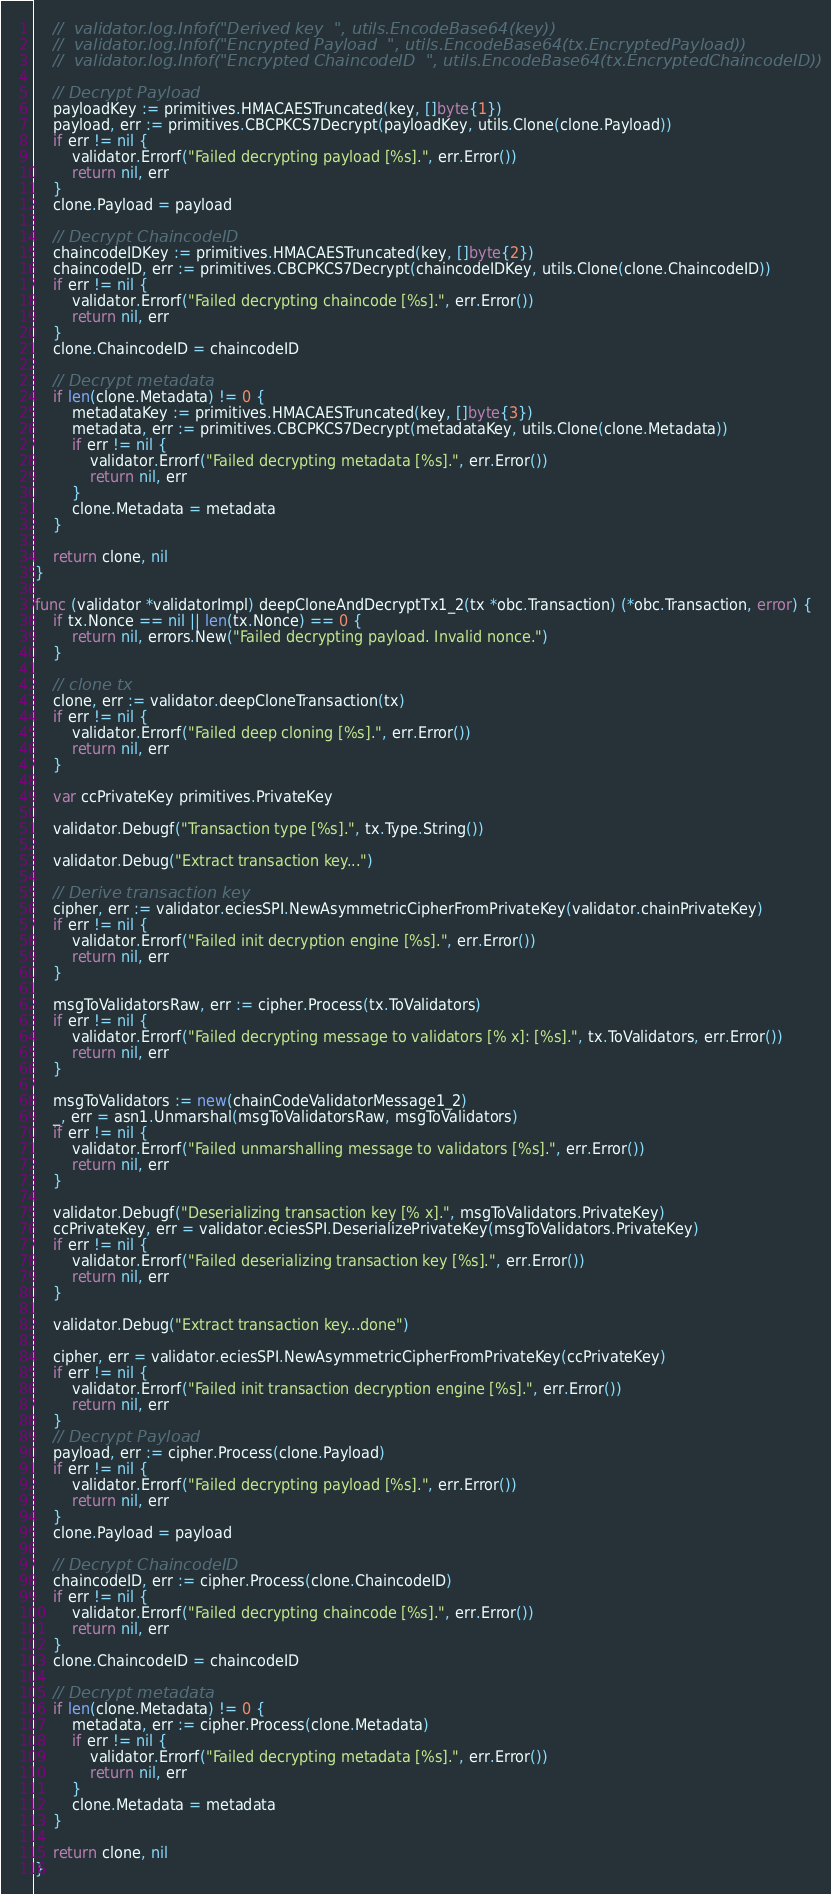<code> <loc_0><loc_0><loc_500><loc_500><_Go_>	//	validator.log.Infof("Derived key  ", utils.EncodeBase64(key))
	//	validator.log.Infof("Encrypted Payload  ", utils.EncodeBase64(tx.EncryptedPayload))
	//	validator.log.Infof("Encrypted ChaincodeID  ", utils.EncodeBase64(tx.EncryptedChaincodeID))

	// Decrypt Payload
	payloadKey := primitives.HMACAESTruncated(key, []byte{1})
	payload, err := primitives.CBCPKCS7Decrypt(payloadKey, utils.Clone(clone.Payload))
	if err != nil {
		validator.Errorf("Failed decrypting payload [%s].", err.Error())
		return nil, err
	}
	clone.Payload = payload

	// Decrypt ChaincodeID
	chaincodeIDKey := primitives.HMACAESTruncated(key, []byte{2})
	chaincodeID, err := primitives.CBCPKCS7Decrypt(chaincodeIDKey, utils.Clone(clone.ChaincodeID))
	if err != nil {
		validator.Errorf("Failed decrypting chaincode [%s].", err.Error())
		return nil, err
	}
	clone.ChaincodeID = chaincodeID

	// Decrypt metadata
	if len(clone.Metadata) != 0 {
		metadataKey := primitives.HMACAESTruncated(key, []byte{3})
		metadata, err := primitives.CBCPKCS7Decrypt(metadataKey, utils.Clone(clone.Metadata))
		if err != nil {
			validator.Errorf("Failed decrypting metadata [%s].", err.Error())
			return nil, err
		}
		clone.Metadata = metadata
	}

	return clone, nil
}

func (validator *validatorImpl) deepCloneAndDecryptTx1_2(tx *obc.Transaction) (*obc.Transaction, error) {
	if tx.Nonce == nil || len(tx.Nonce) == 0 {
		return nil, errors.New("Failed decrypting payload. Invalid nonce.")
	}

	// clone tx
	clone, err := validator.deepCloneTransaction(tx)
	if err != nil {
		validator.Errorf("Failed deep cloning [%s].", err.Error())
		return nil, err
	}

	var ccPrivateKey primitives.PrivateKey

	validator.Debugf("Transaction type [%s].", tx.Type.String())

	validator.Debug("Extract transaction key...")

	// Derive transaction key
	cipher, err := validator.eciesSPI.NewAsymmetricCipherFromPrivateKey(validator.chainPrivateKey)
	if err != nil {
		validator.Errorf("Failed init decryption engine [%s].", err.Error())
		return nil, err
	}

	msgToValidatorsRaw, err := cipher.Process(tx.ToValidators)
	if err != nil {
		validator.Errorf("Failed decrypting message to validators [% x]: [%s].", tx.ToValidators, err.Error())
		return nil, err
	}

	msgToValidators := new(chainCodeValidatorMessage1_2)
	_, err = asn1.Unmarshal(msgToValidatorsRaw, msgToValidators)
	if err != nil {
		validator.Errorf("Failed unmarshalling message to validators [%s].", err.Error())
		return nil, err
	}

	validator.Debugf("Deserializing transaction key [% x].", msgToValidators.PrivateKey)
	ccPrivateKey, err = validator.eciesSPI.DeserializePrivateKey(msgToValidators.PrivateKey)
	if err != nil {
		validator.Errorf("Failed deserializing transaction key [%s].", err.Error())
		return nil, err
	}

	validator.Debug("Extract transaction key...done")

	cipher, err = validator.eciesSPI.NewAsymmetricCipherFromPrivateKey(ccPrivateKey)
	if err != nil {
		validator.Errorf("Failed init transaction decryption engine [%s].", err.Error())
		return nil, err
	}
	// Decrypt Payload
	payload, err := cipher.Process(clone.Payload)
	if err != nil {
		validator.Errorf("Failed decrypting payload [%s].", err.Error())
		return nil, err
	}
	clone.Payload = payload

	// Decrypt ChaincodeID
	chaincodeID, err := cipher.Process(clone.ChaincodeID)
	if err != nil {
		validator.Errorf("Failed decrypting chaincode [%s].", err.Error())
		return nil, err
	}
	clone.ChaincodeID = chaincodeID

	// Decrypt metadata
	if len(clone.Metadata) != 0 {
		metadata, err := cipher.Process(clone.Metadata)
		if err != nil {
			validator.Errorf("Failed decrypting metadata [%s].", err.Error())
			return nil, err
		}
		clone.Metadata = metadata
	}

	return clone, nil
}
</code> 